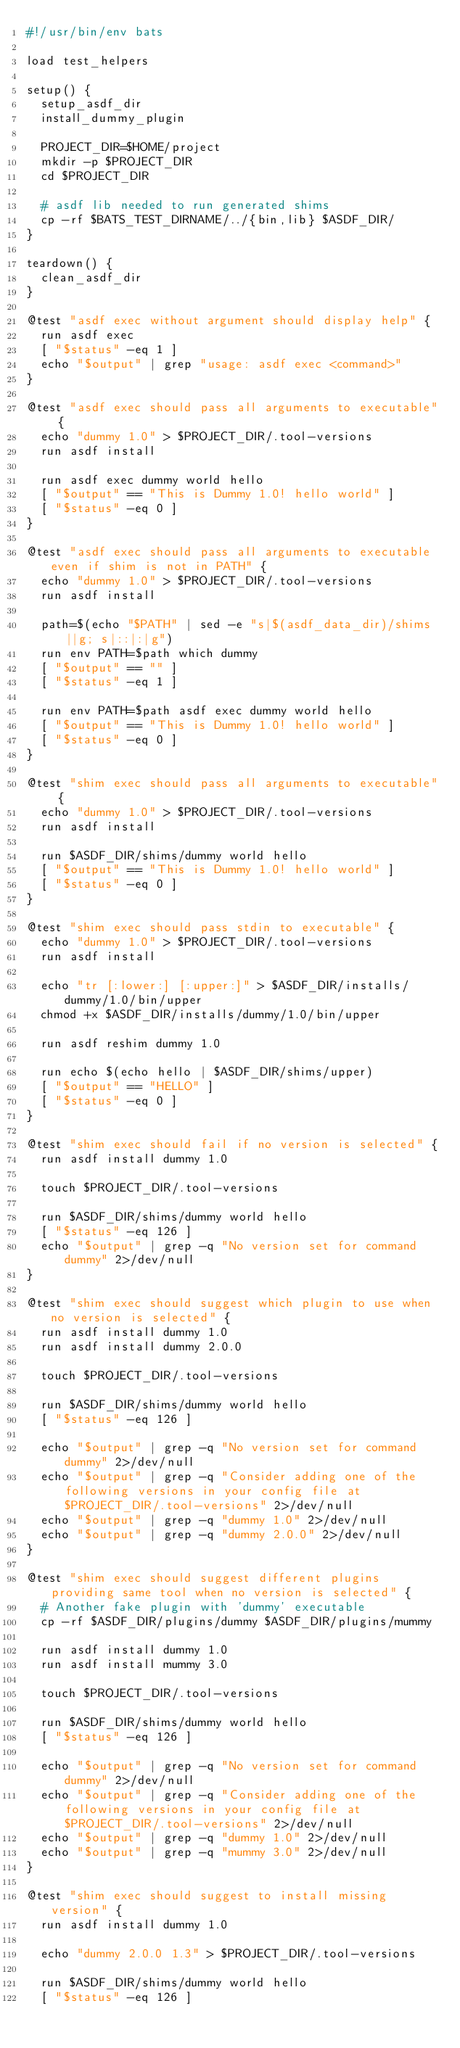Convert code to text. <code><loc_0><loc_0><loc_500><loc_500><_Bash_>#!/usr/bin/env bats

load test_helpers

setup() {
  setup_asdf_dir
  install_dummy_plugin

  PROJECT_DIR=$HOME/project
  mkdir -p $PROJECT_DIR
  cd $PROJECT_DIR

  # asdf lib needed to run generated shims
  cp -rf $BATS_TEST_DIRNAME/../{bin,lib} $ASDF_DIR/
}

teardown() {
  clean_asdf_dir
}

@test "asdf exec without argument should display help" {
  run asdf exec
  [ "$status" -eq 1 ]
  echo "$output" | grep "usage: asdf exec <command>"
}

@test "asdf exec should pass all arguments to executable" {
  echo "dummy 1.0" > $PROJECT_DIR/.tool-versions
  run asdf install

  run asdf exec dummy world hello
  [ "$output" == "This is Dummy 1.0! hello world" ]
  [ "$status" -eq 0 ]
}

@test "asdf exec should pass all arguments to executable even if shim is not in PATH" {
  echo "dummy 1.0" > $PROJECT_DIR/.tool-versions
  run asdf install

  path=$(echo "$PATH" | sed -e "s|$(asdf_data_dir)/shims||g; s|::|:|g")
  run env PATH=$path which dummy
  [ "$output" == "" ]
  [ "$status" -eq 1 ]

  run env PATH=$path asdf exec dummy world hello
  [ "$output" == "This is Dummy 1.0! hello world" ]
  [ "$status" -eq 0 ]
}

@test "shim exec should pass all arguments to executable" {
  echo "dummy 1.0" > $PROJECT_DIR/.tool-versions
  run asdf install

  run $ASDF_DIR/shims/dummy world hello
  [ "$output" == "This is Dummy 1.0! hello world" ]
  [ "$status" -eq 0 ]
}

@test "shim exec should pass stdin to executable" {
  echo "dummy 1.0" > $PROJECT_DIR/.tool-versions
  run asdf install

  echo "tr [:lower:] [:upper:]" > $ASDF_DIR/installs/dummy/1.0/bin/upper
  chmod +x $ASDF_DIR/installs/dummy/1.0/bin/upper

  run asdf reshim dummy 1.0

  run echo $(echo hello | $ASDF_DIR/shims/upper)
  [ "$output" == "HELLO" ]
  [ "$status" -eq 0 ]
}

@test "shim exec should fail if no version is selected" {
  run asdf install dummy 1.0

  touch $PROJECT_DIR/.tool-versions

  run $ASDF_DIR/shims/dummy world hello
  [ "$status" -eq 126 ]
  echo "$output" | grep -q "No version set for command dummy" 2>/dev/null
}

@test "shim exec should suggest which plugin to use when no version is selected" {
  run asdf install dummy 1.0
  run asdf install dummy 2.0.0

  touch $PROJECT_DIR/.tool-versions

  run $ASDF_DIR/shims/dummy world hello
  [ "$status" -eq 126 ]

  echo "$output" | grep -q "No version set for command dummy" 2>/dev/null
  echo "$output" | grep -q "Consider adding one of the following versions in your config file at $PROJECT_DIR/.tool-versions" 2>/dev/null
  echo "$output" | grep -q "dummy 1.0" 2>/dev/null
  echo "$output" | grep -q "dummy 2.0.0" 2>/dev/null
}

@test "shim exec should suggest different plugins providing same tool when no version is selected" {
  # Another fake plugin with 'dummy' executable
  cp -rf $ASDF_DIR/plugins/dummy $ASDF_DIR/plugins/mummy

  run asdf install dummy 1.0
  run asdf install mummy 3.0

  touch $PROJECT_DIR/.tool-versions

  run $ASDF_DIR/shims/dummy world hello
  [ "$status" -eq 126 ]

  echo "$output" | grep -q "No version set for command dummy" 2>/dev/null
  echo "$output" | grep -q "Consider adding one of the following versions in your config file at $PROJECT_DIR/.tool-versions" 2>/dev/null
  echo "$output" | grep -q "dummy 1.0" 2>/dev/null
  echo "$output" | grep -q "mummy 3.0" 2>/dev/null
}

@test "shim exec should suggest to install missing version" {
  run asdf install dummy 1.0

  echo "dummy 2.0.0 1.3" > $PROJECT_DIR/.tool-versions

  run $ASDF_DIR/shims/dummy world hello
  [ "$status" -eq 126 ]</code> 